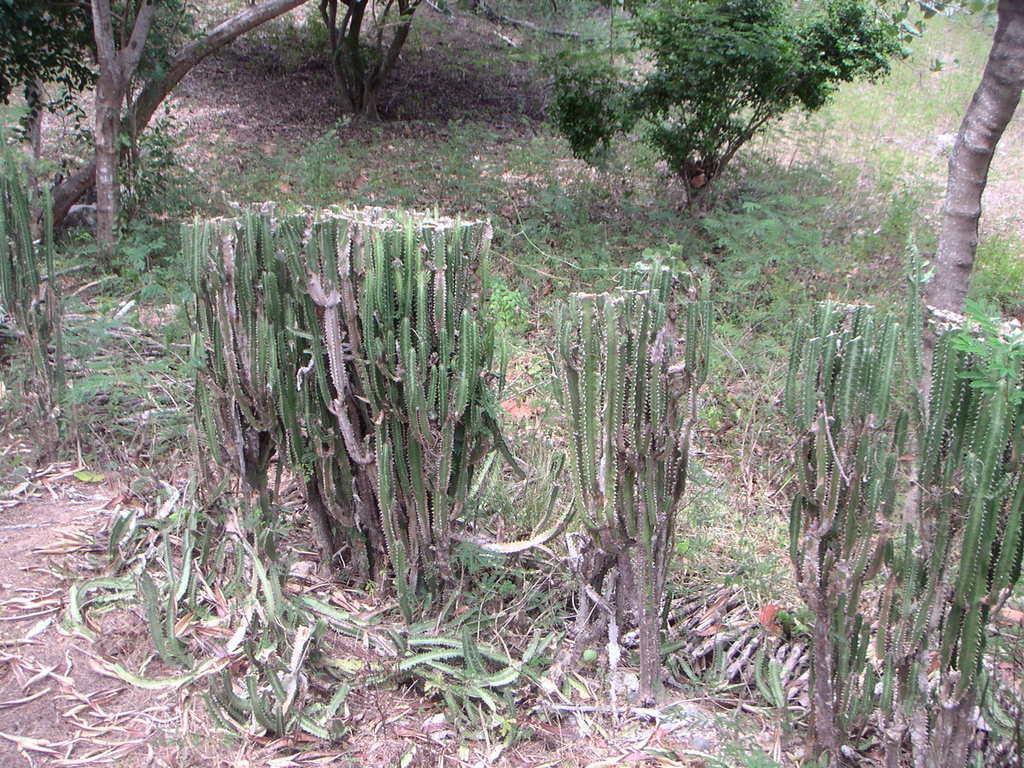How would you summarize this image in a sentence or two? In this image we can see some cactus plants. We can also see some dried leaves on the ground, the bark of a tree and some trees. 